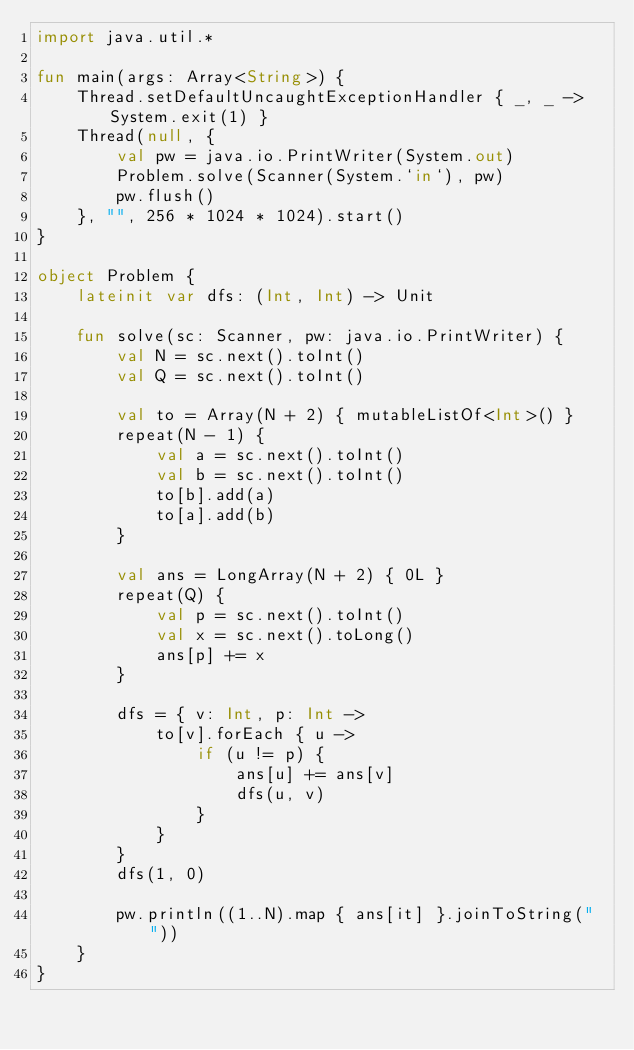<code> <loc_0><loc_0><loc_500><loc_500><_Kotlin_>import java.util.*

fun main(args: Array<String>) {
    Thread.setDefaultUncaughtExceptionHandler { _, _ -> System.exit(1) }
    Thread(null, {
        val pw = java.io.PrintWriter(System.out)
        Problem.solve(Scanner(System.`in`), pw)
        pw.flush()
    }, "", 256 * 1024 * 1024).start()
}

object Problem {
    lateinit var dfs: (Int, Int) -> Unit

    fun solve(sc: Scanner, pw: java.io.PrintWriter) {
        val N = sc.next().toInt()
        val Q = sc.next().toInt()

        val to = Array(N + 2) { mutableListOf<Int>() }
        repeat(N - 1) {
            val a = sc.next().toInt()
            val b = sc.next().toInt()
            to[b].add(a)
            to[a].add(b)
        }

        val ans = LongArray(N + 2) { 0L }
        repeat(Q) {
            val p = sc.next().toInt()
            val x = sc.next().toLong()
            ans[p] += x
        }

        dfs = { v: Int, p: Int ->
            to[v].forEach { u ->
                if (u != p) {
                    ans[u] += ans[v]
                    dfs(u, v)
                }
            }
        }
        dfs(1, 0)

        pw.println((1..N).map { ans[it] }.joinToString(" "))
    }
}</code> 